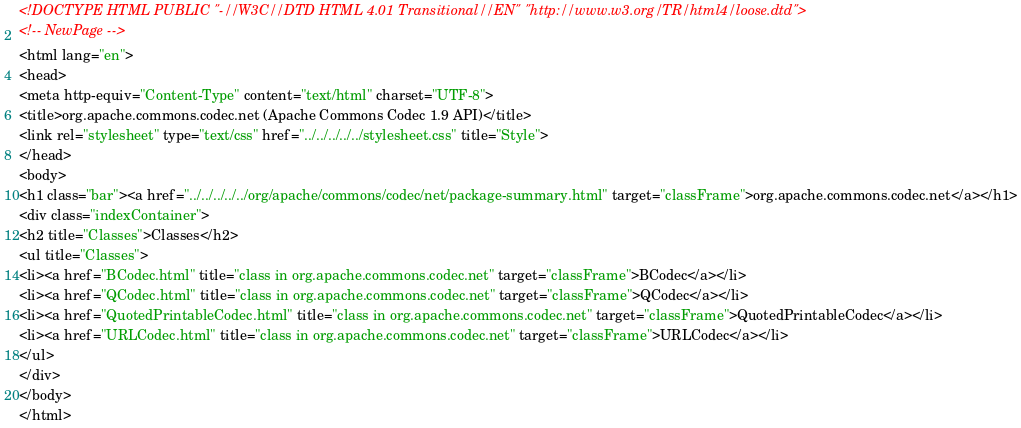<code> <loc_0><loc_0><loc_500><loc_500><_HTML_><!DOCTYPE HTML PUBLIC "-//W3C//DTD HTML 4.01 Transitional//EN" "http://www.w3.org/TR/html4/loose.dtd">
<!-- NewPage -->
<html lang="en">
<head>
<meta http-equiv="Content-Type" content="text/html" charset="UTF-8">
<title>org.apache.commons.codec.net (Apache Commons Codec 1.9 API)</title>
<link rel="stylesheet" type="text/css" href="../../../../../stylesheet.css" title="Style">
</head>
<body>
<h1 class="bar"><a href="../../../../../org/apache/commons/codec/net/package-summary.html" target="classFrame">org.apache.commons.codec.net</a></h1>
<div class="indexContainer">
<h2 title="Classes">Classes</h2>
<ul title="Classes">
<li><a href="BCodec.html" title="class in org.apache.commons.codec.net" target="classFrame">BCodec</a></li>
<li><a href="QCodec.html" title="class in org.apache.commons.codec.net" target="classFrame">QCodec</a></li>
<li><a href="QuotedPrintableCodec.html" title="class in org.apache.commons.codec.net" target="classFrame">QuotedPrintableCodec</a></li>
<li><a href="URLCodec.html" title="class in org.apache.commons.codec.net" target="classFrame">URLCodec</a></li>
</ul>
</div>
</body>
</html>
</code> 